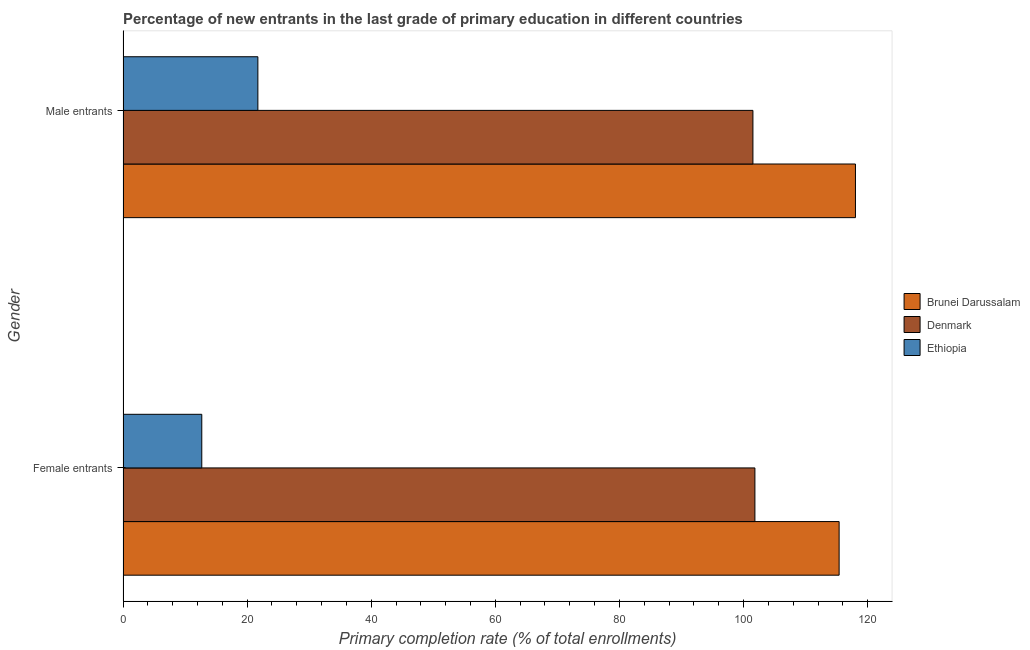How many different coloured bars are there?
Your answer should be very brief. 3. How many groups of bars are there?
Provide a succinct answer. 2. Are the number of bars per tick equal to the number of legend labels?
Your answer should be compact. Yes. How many bars are there on the 2nd tick from the bottom?
Provide a succinct answer. 3. What is the label of the 2nd group of bars from the top?
Provide a short and direct response. Female entrants. What is the primary completion rate of female entrants in Brunei Darussalam?
Ensure brevity in your answer.  115.4. Across all countries, what is the maximum primary completion rate of female entrants?
Your response must be concise. 115.4. Across all countries, what is the minimum primary completion rate of female entrants?
Provide a succinct answer. 12.7. In which country was the primary completion rate of male entrants maximum?
Provide a short and direct response. Brunei Darussalam. In which country was the primary completion rate of male entrants minimum?
Offer a very short reply. Ethiopia. What is the total primary completion rate of female entrants in the graph?
Make the answer very short. 229.93. What is the difference between the primary completion rate of male entrants in Denmark and that in Brunei Darussalam?
Give a very brief answer. -16.52. What is the difference between the primary completion rate of male entrants in Brunei Darussalam and the primary completion rate of female entrants in Denmark?
Offer a terse response. 16.2. What is the average primary completion rate of female entrants per country?
Offer a very short reply. 76.64. What is the difference between the primary completion rate of male entrants and primary completion rate of female entrants in Ethiopia?
Keep it short and to the point. 9.04. What is the ratio of the primary completion rate of female entrants in Brunei Darussalam to that in Denmark?
Offer a very short reply. 1.13. Is the primary completion rate of male entrants in Brunei Darussalam less than that in Denmark?
Ensure brevity in your answer.  No. In how many countries, is the primary completion rate of female entrants greater than the average primary completion rate of female entrants taken over all countries?
Offer a very short reply. 2. What does the 2nd bar from the top in Female entrants represents?
Offer a terse response. Denmark. What does the 1st bar from the bottom in Female entrants represents?
Your answer should be compact. Brunei Darussalam. How many bars are there?
Give a very brief answer. 6. How many countries are there in the graph?
Your answer should be compact. 3. Does the graph contain grids?
Offer a very short reply. No. Where does the legend appear in the graph?
Offer a terse response. Center right. How are the legend labels stacked?
Keep it short and to the point. Vertical. What is the title of the graph?
Provide a short and direct response. Percentage of new entrants in the last grade of primary education in different countries. What is the label or title of the X-axis?
Keep it short and to the point. Primary completion rate (% of total enrollments). What is the Primary completion rate (% of total enrollments) in Brunei Darussalam in Female entrants?
Your response must be concise. 115.4. What is the Primary completion rate (% of total enrollments) of Denmark in Female entrants?
Provide a short and direct response. 101.83. What is the Primary completion rate (% of total enrollments) of Ethiopia in Female entrants?
Your answer should be very brief. 12.7. What is the Primary completion rate (% of total enrollments) in Brunei Darussalam in Male entrants?
Provide a succinct answer. 118.03. What is the Primary completion rate (% of total enrollments) of Denmark in Male entrants?
Ensure brevity in your answer.  101.51. What is the Primary completion rate (% of total enrollments) in Ethiopia in Male entrants?
Your response must be concise. 21.73. Across all Gender, what is the maximum Primary completion rate (% of total enrollments) of Brunei Darussalam?
Ensure brevity in your answer.  118.03. Across all Gender, what is the maximum Primary completion rate (% of total enrollments) of Denmark?
Ensure brevity in your answer.  101.83. Across all Gender, what is the maximum Primary completion rate (% of total enrollments) of Ethiopia?
Your answer should be very brief. 21.73. Across all Gender, what is the minimum Primary completion rate (% of total enrollments) in Brunei Darussalam?
Give a very brief answer. 115.4. Across all Gender, what is the minimum Primary completion rate (% of total enrollments) in Denmark?
Provide a succinct answer. 101.51. Across all Gender, what is the minimum Primary completion rate (% of total enrollments) of Ethiopia?
Provide a succinct answer. 12.7. What is the total Primary completion rate (% of total enrollments) of Brunei Darussalam in the graph?
Provide a succinct answer. 233.44. What is the total Primary completion rate (% of total enrollments) in Denmark in the graph?
Your response must be concise. 203.34. What is the total Primary completion rate (% of total enrollments) in Ethiopia in the graph?
Make the answer very short. 34.43. What is the difference between the Primary completion rate (% of total enrollments) of Brunei Darussalam in Female entrants and that in Male entrants?
Ensure brevity in your answer.  -2.63. What is the difference between the Primary completion rate (% of total enrollments) of Denmark in Female entrants and that in Male entrants?
Make the answer very short. 0.32. What is the difference between the Primary completion rate (% of total enrollments) of Ethiopia in Female entrants and that in Male entrants?
Make the answer very short. -9.04. What is the difference between the Primary completion rate (% of total enrollments) of Brunei Darussalam in Female entrants and the Primary completion rate (% of total enrollments) of Denmark in Male entrants?
Provide a short and direct response. 13.89. What is the difference between the Primary completion rate (% of total enrollments) in Brunei Darussalam in Female entrants and the Primary completion rate (% of total enrollments) in Ethiopia in Male entrants?
Provide a short and direct response. 93.67. What is the difference between the Primary completion rate (% of total enrollments) in Denmark in Female entrants and the Primary completion rate (% of total enrollments) in Ethiopia in Male entrants?
Offer a very short reply. 80.1. What is the average Primary completion rate (% of total enrollments) in Brunei Darussalam per Gender?
Your answer should be compact. 116.72. What is the average Primary completion rate (% of total enrollments) in Denmark per Gender?
Provide a short and direct response. 101.67. What is the average Primary completion rate (% of total enrollments) of Ethiopia per Gender?
Give a very brief answer. 17.22. What is the difference between the Primary completion rate (% of total enrollments) of Brunei Darussalam and Primary completion rate (% of total enrollments) of Denmark in Female entrants?
Ensure brevity in your answer.  13.57. What is the difference between the Primary completion rate (% of total enrollments) of Brunei Darussalam and Primary completion rate (% of total enrollments) of Ethiopia in Female entrants?
Keep it short and to the point. 102.71. What is the difference between the Primary completion rate (% of total enrollments) of Denmark and Primary completion rate (% of total enrollments) of Ethiopia in Female entrants?
Provide a succinct answer. 89.14. What is the difference between the Primary completion rate (% of total enrollments) in Brunei Darussalam and Primary completion rate (% of total enrollments) in Denmark in Male entrants?
Keep it short and to the point. 16.52. What is the difference between the Primary completion rate (% of total enrollments) in Brunei Darussalam and Primary completion rate (% of total enrollments) in Ethiopia in Male entrants?
Keep it short and to the point. 96.3. What is the difference between the Primary completion rate (% of total enrollments) of Denmark and Primary completion rate (% of total enrollments) of Ethiopia in Male entrants?
Your answer should be very brief. 79.78. What is the ratio of the Primary completion rate (% of total enrollments) of Brunei Darussalam in Female entrants to that in Male entrants?
Your answer should be very brief. 0.98. What is the ratio of the Primary completion rate (% of total enrollments) in Denmark in Female entrants to that in Male entrants?
Provide a short and direct response. 1. What is the ratio of the Primary completion rate (% of total enrollments) of Ethiopia in Female entrants to that in Male entrants?
Provide a succinct answer. 0.58. What is the difference between the highest and the second highest Primary completion rate (% of total enrollments) of Brunei Darussalam?
Provide a succinct answer. 2.63. What is the difference between the highest and the second highest Primary completion rate (% of total enrollments) of Denmark?
Your answer should be compact. 0.32. What is the difference between the highest and the second highest Primary completion rate (% of total enrollments) in Ethiopia?
Offer a very short reply. 9.04. What is the difference between the highest and the lowest Primary completion rate (% of total enrollments) in Brunei Darussalam?
Keep it short and to the point. 2.63. What is the difference between the highest and the lowest Primary completion rate (% of total enrollments) in Denmark?
Your response must be concise. 0.32. What is the difference between the highest and the lowest Primary completion rate (% of total enrollments) in Ethiopia?
Your answer should be very brief. 9.04. 